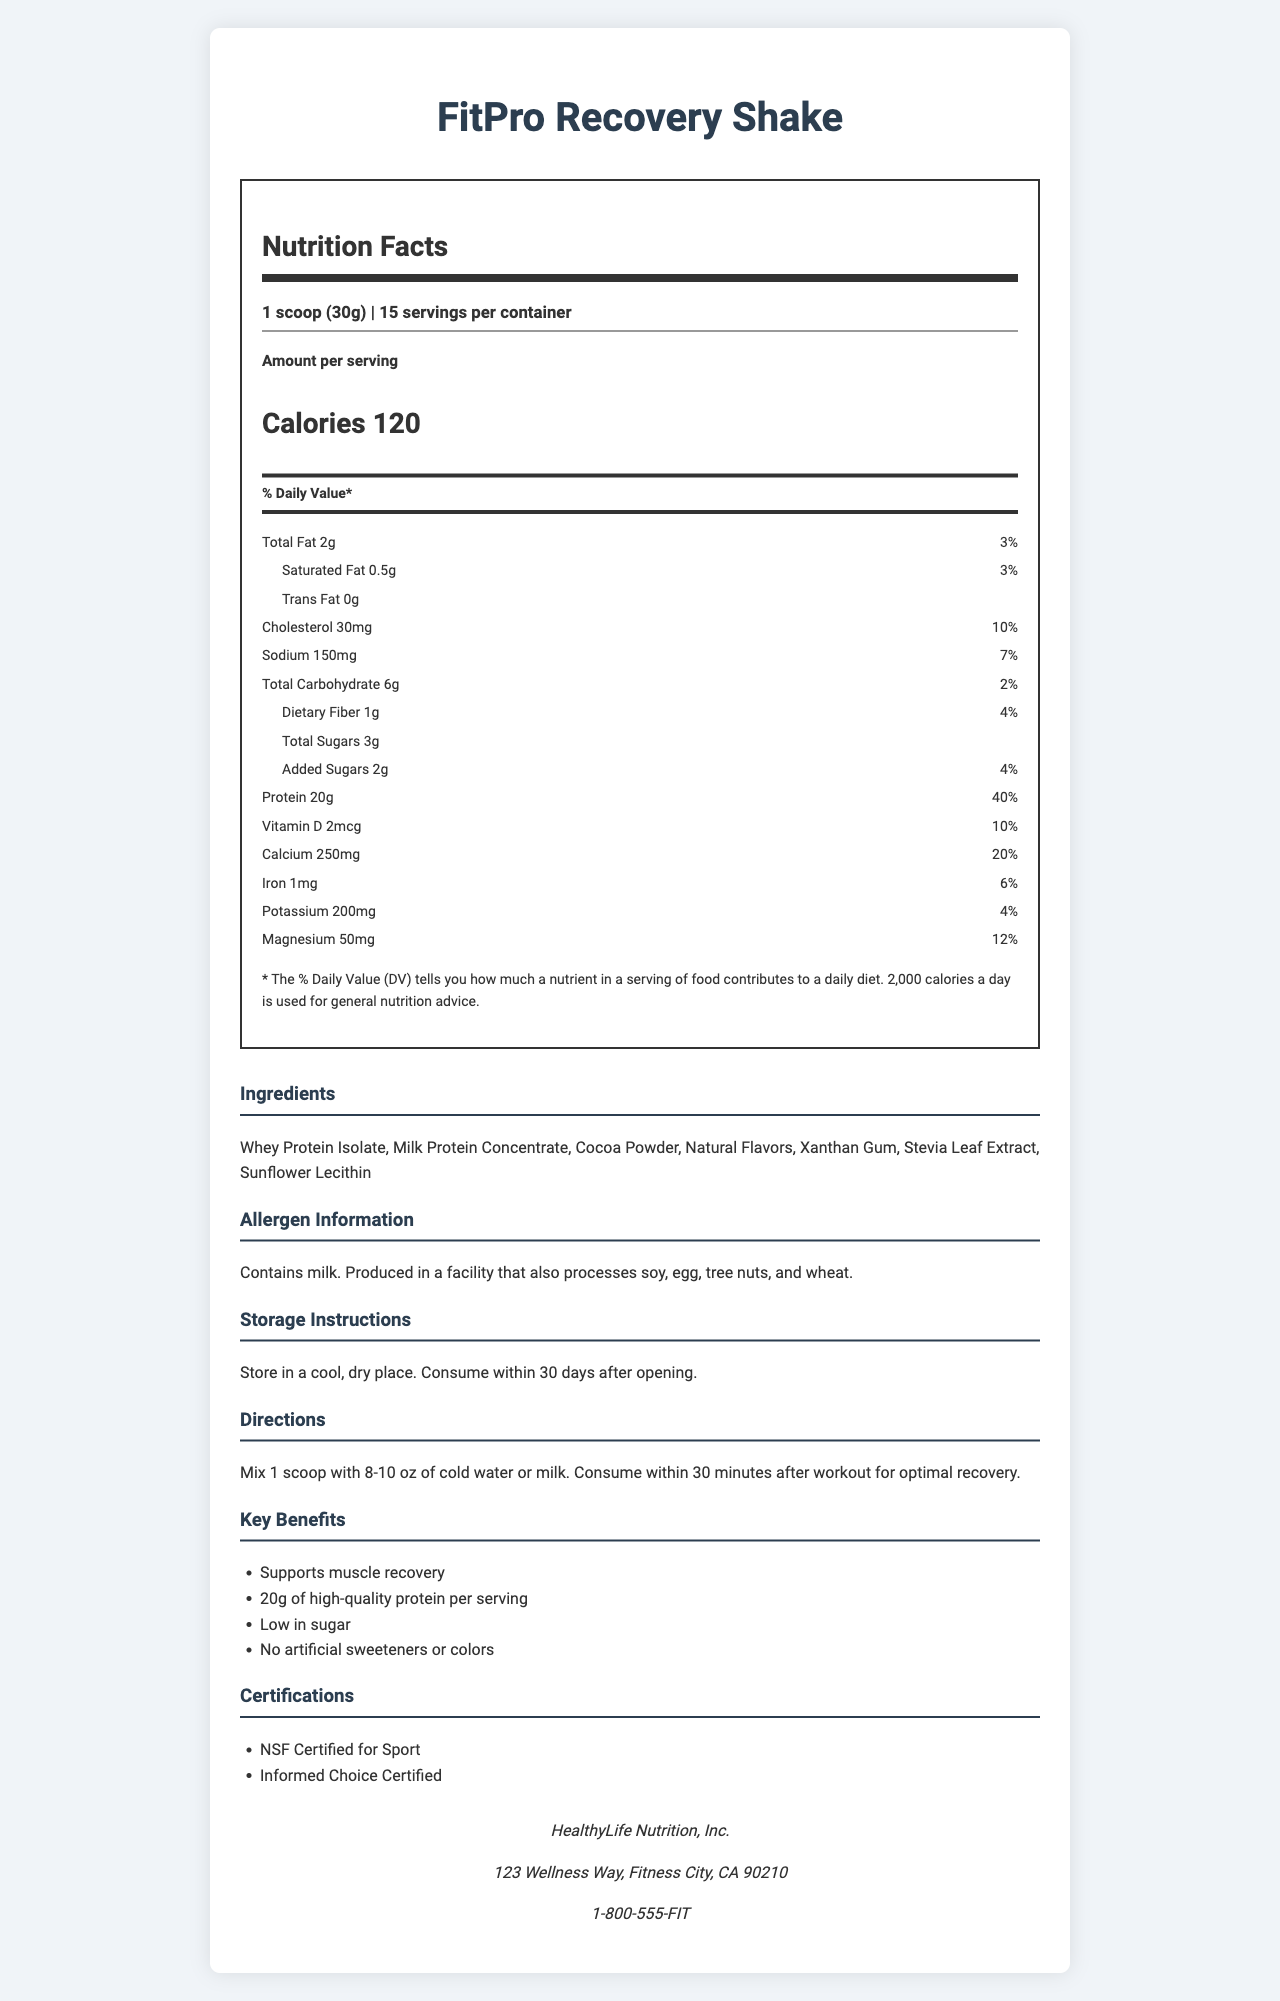what is the serving size of the FitPro Recovery Shake? The serving size is specified at the top of the Nutrition Facts section as "1 scoop (30g)".
Answer: 1 scoop (30g) how many calories are in one serving? The number of calories per serving is listed as 120 in the Nutrition Facts section.
Answer: 120 what is the total fat content per serving? The total fat content per serving is listed as 2g.
Answer: 2g which certifications does the FitPro Recovery Shake have? The certifications are listed under the "Certifications" section as "NSF Certified for Sport" and "Informed Choice Certified".
Answer: NSF Certified for Sport and Informed Choice Certified how much protein is there per serving? The Nutrition Facts section states that there is 20g of protein per serving.
Answer: 20g how should FitPro Recovery Shake be stored? The storage instructions are listed in the "Storage Instructions" section.
Answer: Store in a cool, dry place. Consume within 30 days after opening. which of the following is not an ingredient in the FitPro Recovery Shake? A. Whey Protein Isolate B. Milk Protein Concentrate C. Corn Syrup D. Stevia Leaf Extract The ingredients listed do not include Corn Syrup.
Answer: C. Corn Syrup what is the daily value percentage of calcium provided by one serving? The daily value percentage of calcium provided by one serving is listed as 20%.
Answer: 20% does the product contain artificial sweeteners or colors? The marketing claims state that the product contains no artificial sweeteners or colors.
Answer: No are there any allergens in this product? The allergen information states that the product contains milk and is produced in a facility that also processes soy, egg, tree nuts, and wheat.
Answer: Yes how many servings are there per container? The number of servings per container is listed as 15 in the Nutrition Facts section.
Answer: 15 which ingredient listed is a natural flavor enhancer? Stevia Leaf Extract is commonly used as a natural flavor enhancer and is listed as one of the ingredients.
Answer: Stevia Leaf Extract what is the main purpose of consuming FitPro Recovery Shake after a workout? A. To gain weight B. To support muscle recovery C. To increase sugar intake D. To replace meals The main purpose is stated in the marketing claims as "Supports muscle recovery".
Answer: B. To support muscle recovery summarize the key points of the FitPro Recovery Shake. The shake is designed to support muscle recovery with 20g of protein per serving. It has certifications like NSF Certified for Sport and Informed Choice Certified, contains no artificial additives, and includes key ingredients and allergens. The product emphasizes the importance of proper storage and timely consumption after opening.
Answer: The FitPro Recovery Shake is a protein shake designed for post-workout recovery, providing 20g of protein per serving with 120 calories. It is low in sugar and contains no artificial sweeteners or colors. The shake is NSF Certified for Sport and Informed Choice Certified, made with ingredients such as Whey Protein Isolate, Milk Protein Concentrate, and Stevia Leaf Extract. It contains allergens like milk and should be stored in a cool, dry place and consumed within 30 days after opening. how much sugar is added per serving? The amount of added sugars per serving is listed as 2g in the Nutrition Facts section.
Answer: 2g what is the percentage of daily value for magnesium provided by each serving? The daily value percentage of magnesium provided by one serving is listed as 12%.
Answer: 12% what is the base of protein sources in the shake? The ingredients list at the bottom of the Nutrition Facts highlights Whey Protein Isolate and Milk Protein Concentrate as the main protein sources.
Answer: The shake primarily uses Whey Protein Isolate and Milk Protein Concentrate as its protein sources. who is the manufacturer of FitPro Recovery Shake? The manufacturer information section lists HealthyLife Nutrition, Inc. as the manufacturer.
Answer: HealthyLife Nutrition, Inc. is the product suitable for people with tree nut allergies? The allergen information states that it is produced in a facility that also processes tree nuts, which may not be suitable for people with tree nut allergies.
Answer: Not necessarily, as it is produced in a facility that processes tree nuts. what is the phone number for HealthyLife Nutrition, Inc.? The manufacturer information section provides the phone number as 1-800-555-FIT.
Answer: 1-800-555-FIT what are the directions for consuming the FitPro Recovery Shake? The directions section provides specific instructions on how to mix and consume the shake.
Answer: Mix 1 scoop with 8-10 oz of cold water or milk. Consume within 30 minutes after workout for optimal recovery. 